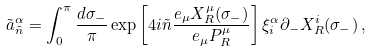<formula> <loc_0><loc_0><loc_500><loc_500>\tilde { a } _ { \tilde { n } } ^ { \alpha } = \int _ { 0 } ^ { \pi } \frac { d \sigma _ { - } } { \pi } \exp \left [ 4 i \tilde { n } \frac { e _ { \mu } X _ { R } ^ { \mu } ( \sigma _ { - } ) } { e _ { \mu } P _ { R } ^ { \mu } } \right ] \xi _ { i } ^ { \alpha } \partial _ { - } X _ { R } ^ { i } ( \sigma _ { - } ) \, ,</formula> 